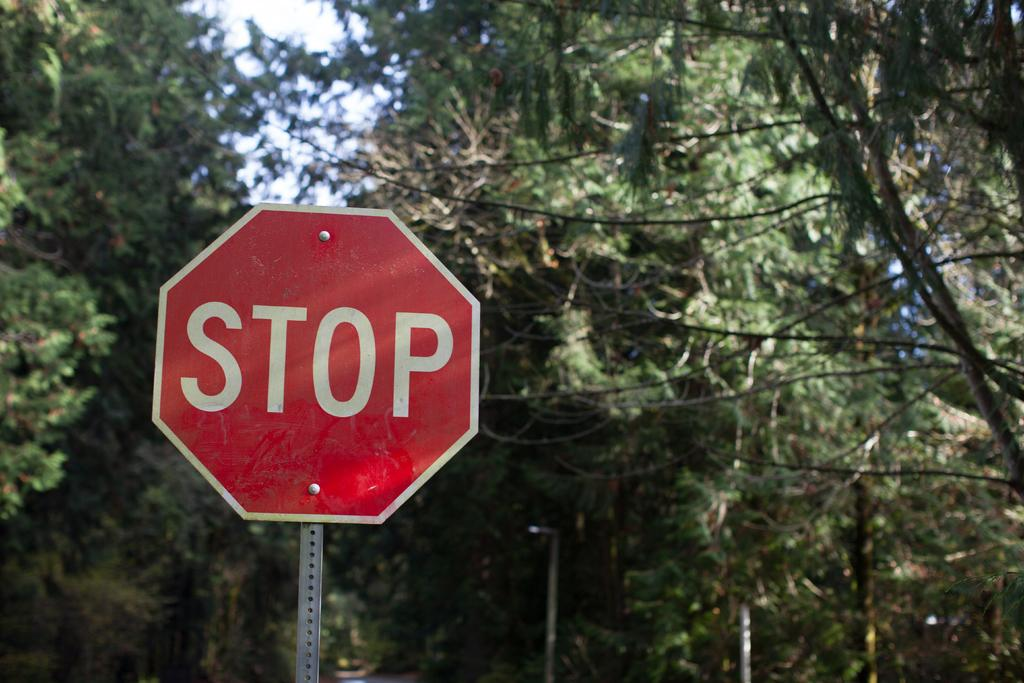What is written on the board in the image? The image contains a board with text, but the specific text is not mentioned in the facts provided. What else can be seen besides the board in the image? There are poles and trees visible in the image. What is visible in the background of the image? The sky is visible in the image. Is there any salt visible on the poles in the image? There is no mention of salt in the image, and it is not visible on the poles. What type of snake can be seen slithering through the trees in the image? There is no snake present in the image; it only features a board with text, poles, trees, and the sky. 